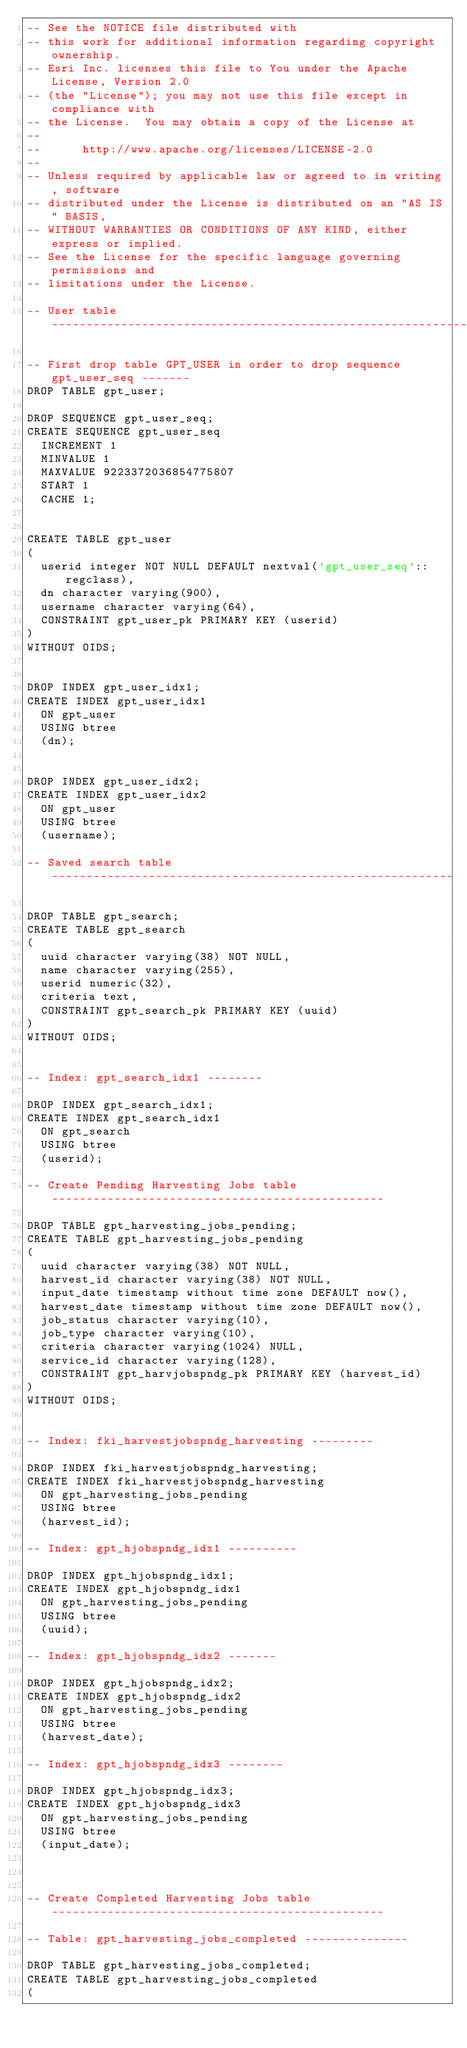<code> <loc_0><loc_0><loc_500><loc_500><_SQL_>-- See the NOTICE file distributed with
-- this work for additional information regarding copyright ownership.
-- Esri Inc. licenses this file to You under the Apache License, Version 2.0
-- (the "License"); you may not use this file except in compliance with
-- the License.  You may obtain a copy of the License at
-- 
--      http://www.apache.org/licenses/LICENSE-2.0
-- 
-- Unless required by applicable law or agreed to in writing, software
-- distributed under the License is distributed on an "AS IS" BASIS,
-- WITHOUT WARRANTIES OR CONDITIONS OF ANY KIND, either express or implied.
-- See the License for the specific language governing permissions and
-- limitations under the License.

-- User table -------------------------------------------------------------------

-- First drop table GPT_USER in order to drop sequence gpt_user_seq -------
DROP TABLE gpt_user;

DROP SEQUENCE gpt_user_seq;
CREATE SEQUENCE gpt_user_seq
  INCREMENT 1
  MINVALUE 1
  MAXVALUE 9223372036854775807
  START 1
  CACHE 1;


CREATE TABLE gpt_user
(
  userid integer NOT NULL DEFAULT nextval('gpt_user_seq'::regclass),
  dn character varying(900),
  username character varying(64),
  CONSTRAINT gpt_user_pk PRIMARY KEY (userid)
) 
WITHOUT OIDS;


DROP INDEX gpt_user_idx1;
CREATE INDEX gpt_user_idx1
  ON gpt_user
  USING btree
  (dn);


DROP INDEX gpt_user_idx2;
CREATE INDEX gpt_user_idx2
  ON gpt_user
  USING btree
  (username); 

-- Saved search table ----------------------------------------------------------

DROP TABLE gpt_search;
CREATE TABLE gpt_search
(
  uuid character varying(38) NOT NULL,
  name character varying(255),
  userid numeric(32),
  criteria text,
  CONSTRAINT gpt_search_pk PRIMARY KEY (uuid)
) 
WITHOUT OIDS;


-- Index: gpt_search_idx1 --------

DROP INDEX gpt_search_idx1;
CREATE INDEX gpt_search_idx1
  ON gpt_search
  USING btree
  (userid);

-- Create Pending Harvesting Jobs table ------------------------------------------------

DROP TABLE gpt_harvesting_jobs_pending;
CREATE TABLE gpt_harvesting_jobs_pending
(
  uuid character varying(38) NOT NULL,
  harvest_id character varying(38) NOT NULL,
  input_date timestamp without time zone DEFAULT now(),
  harvest_date timestamp without time zone DEFAULT now(),
  job_status character varying(10),
  job_type character varying(10),
  criteria character varying(1024) NULL,
  service_id character varying(128),
  CONSTRAINT gpt_harvjobspndg_pk PRIMARY KEY (harvest_id)
) 
WITHOUT OIDS;


-- Index: fki_harvestjobspndg_harvesting ---------

DROP INDEX fki_harvestjobspndg_harvesting;
CREATE INDEX fki_harvestjobspndg_harvesting
  ON gpt_harvesting_jobs_pending
  USING btree
  (harvest_id);

-- Index: gpt_hjobspndg_idx1 ----------

DROP INDEX gpt_hjobspndg_idx1;
CREATE INDEX gpt_hjobspndg_idx1
  ON gpt_harvesting_jobs_pending
  USING btree
  (uuid);

-- Index: gpt_hjobspndg_idx2 -------

DROP INDEX gpt_hjobspndg_idx2;
CREATE INDEX gpt_hjobspndg_idx2
  ON gpt_harvesting_jobs_pending
  USING btree
  (harvest_date);

-- Index: gpt_hjobspndg_idx3 -------- 

DROP INDEX gpt_hjobspndg_idx3;
CREATE INDEX gpt_hjobspndg_idx3
  ON gpt_harvesting_jobs_pending
  USING btree
  (input_date);



-- Create Completed Harvesting Jobs table ------------------------------------------------

-- Table: gpt_harvesting_jobs_completed ---------------

DROP TABLE gpt_harvesting_jobs_completed;
CREATE TABLE gpt_harvesting_jobs_completed
(</code> 